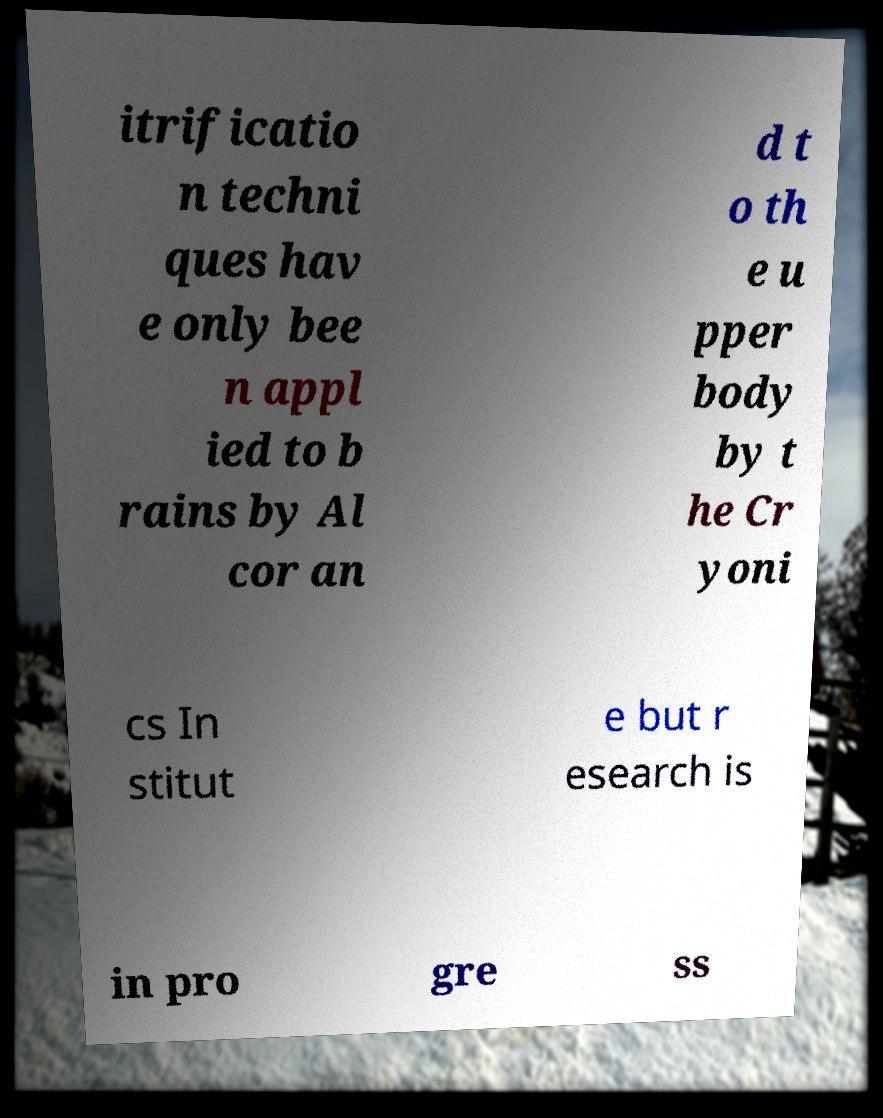Could you assist in decoding the text presented in this image and type it out clearly? itrificatio n techni ques hav e only bee n appl ied to b rains by Al cor an d t o th e u pper body by t he Cr yoni cs In stitut e but r esearch is in pro gre ss 